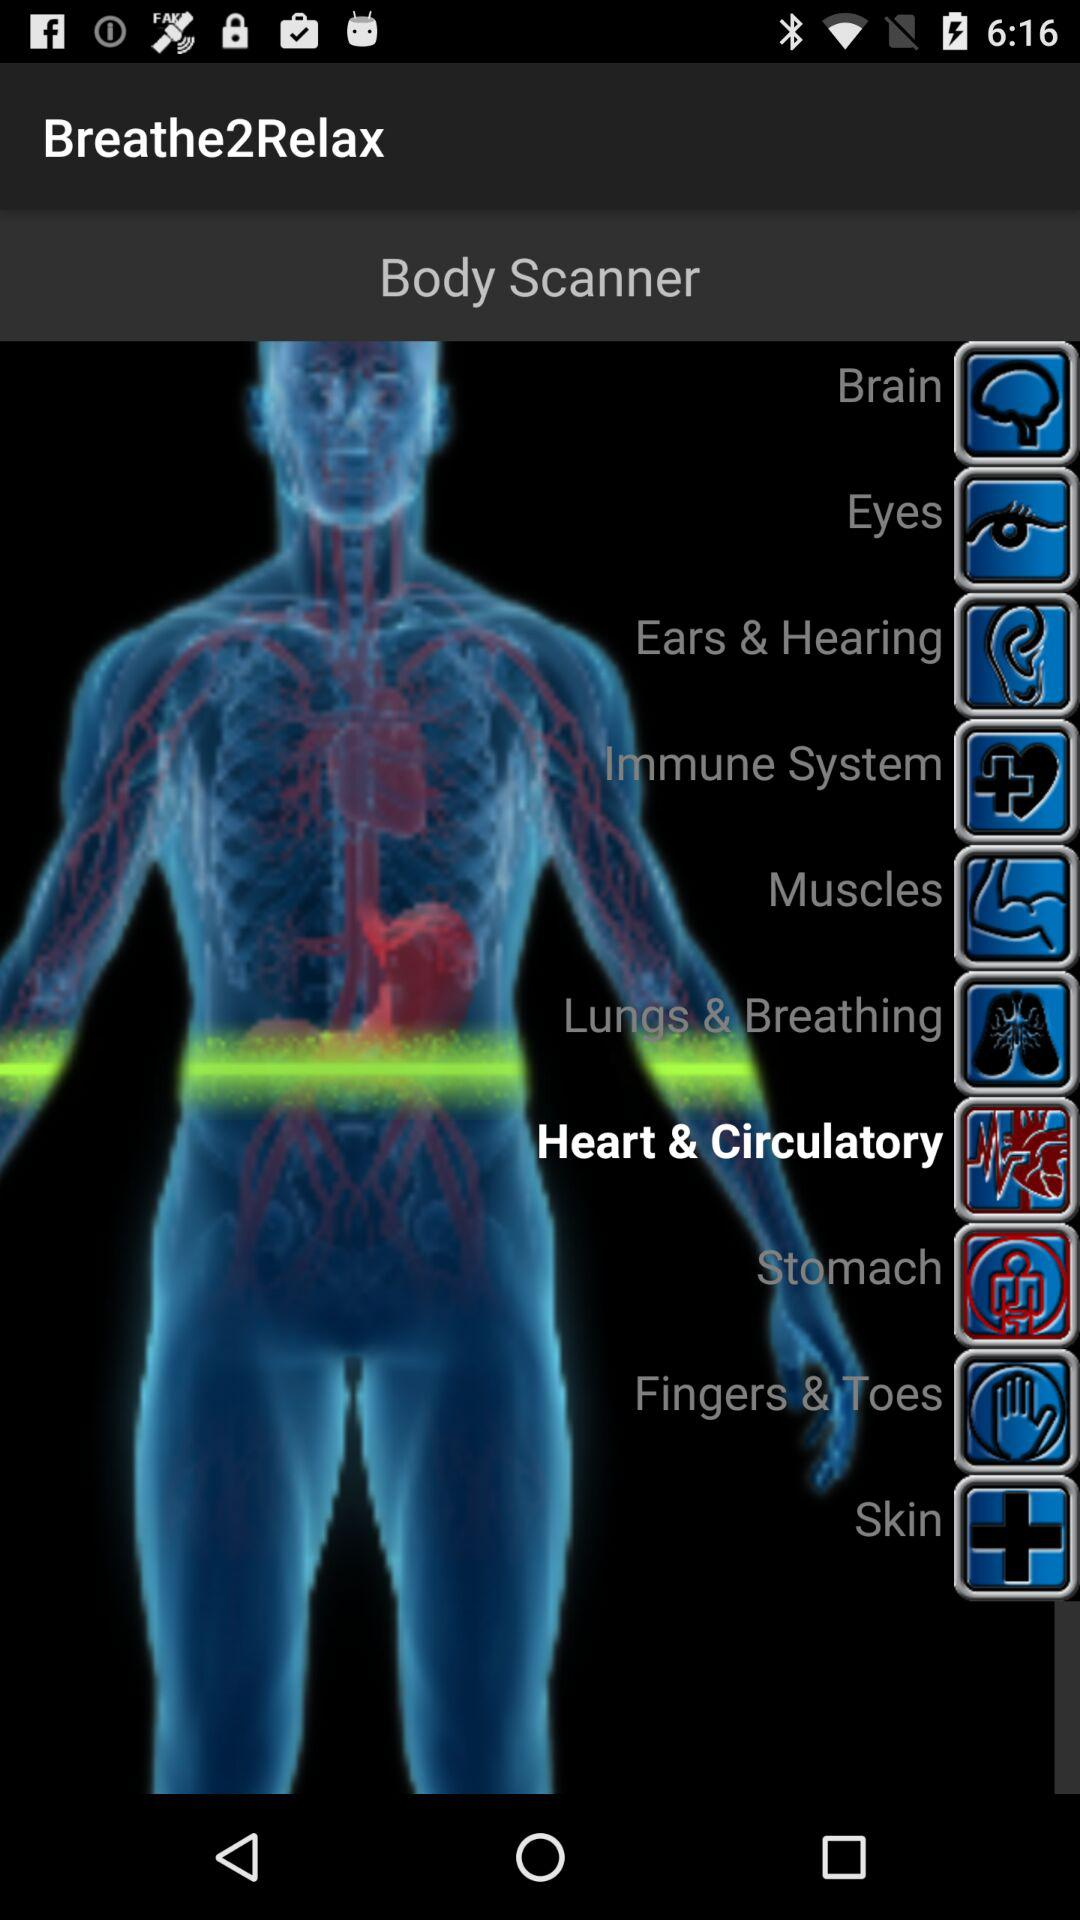Which option has been selected? The selected option is "Heart & Circulatory". 